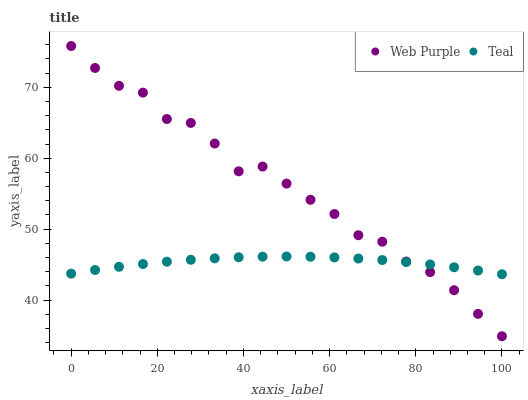Does Teal have the minimum area under the curve?
Answer yes or no. Yes. Does Web Purple have the maximum area under the curve?
Answer yes or no. Yes. Does Teal have the maximum area under the curve?
Answer yes or no. No. Is Teal the smoothest?
Answer yes or no. Yes. Is Web Purple the roughest?
Answer yes or no. Yes. Is Teal the roughest?
Answer yes or no. No. Does Web Purple have the lowest value?
Answer yes or no. Yes. Does Teal have the lowest value?
Answer yes or no. No. Does Web Purple have the highest value?
Answer yes or no. Yes. Does Teal have the highest value?
Answer yes or no. No. Does Web Purple intersect Teal?
Answer yes or no. Yes. Is Web Purple less than Teal?
Answer yes or no. No. Is Web Purple greater than Teal?
Answer yes or no. No. 